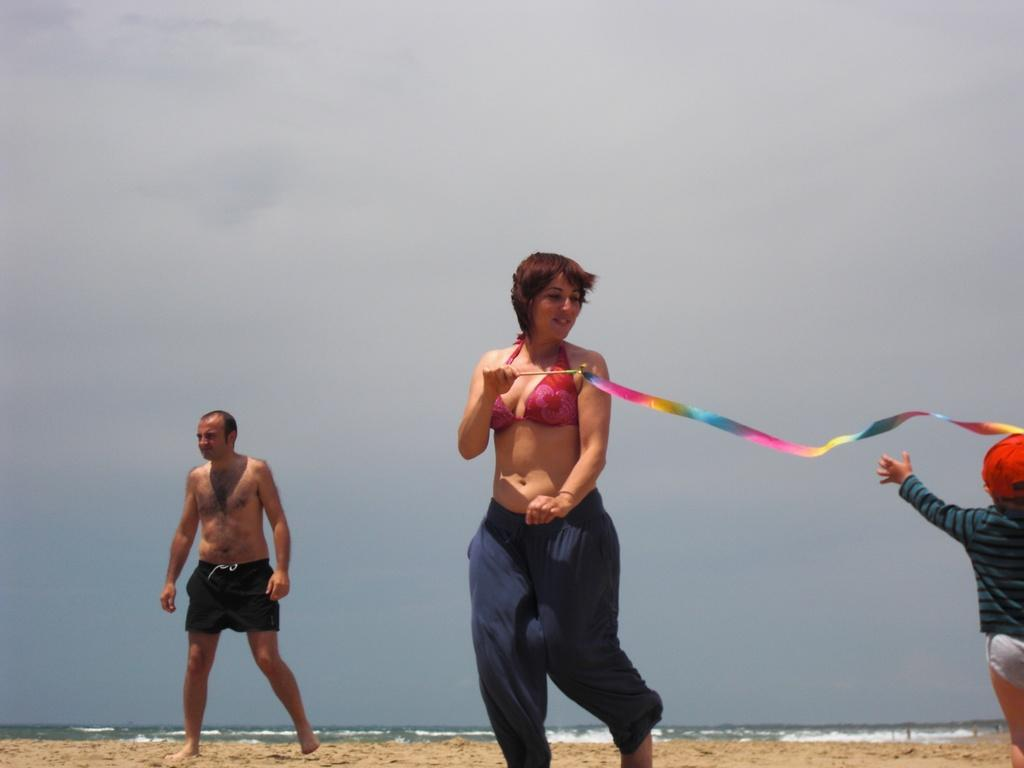How many people are in the image? There are three persons in the image. What are the people doing in the image? One of the persons is holding an object. What type of surface is visible at the bottom of the image? There is sand and water visible at the bottom of the image. What can be seen in the background of the image? The sky is visible in the background of the image. What type of coal can be seen in the image? There is no coal present in the image. How many planes are flying in the sky in the image? There are no planes visible in the image; only the sky is visible in the background. 